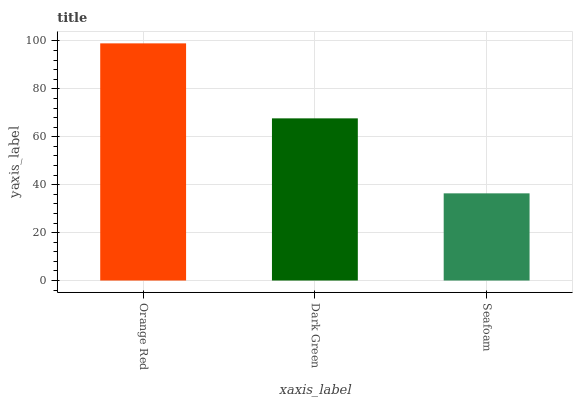Is Seafoam the minimum?
Answer yes or no. Yes. Is Orange Red the maximum?
Answer yes or no. Yes. Is Dark Green the minimum?
Answer yes or no. No. Is Dark Green the maximum?
Answer yes or no. No. Is Orange Red greater than Dark Green?
Answer yes or no. Yes. Is Dark Green less than Orange Red?
Answer yes or no. Yes. Is Dark Green greater than Orange Red?
Answer yes or no. No. Is Orange Red less than Dark Green?
Answer yes or no. No. Is Dark Green the high median?
Answer yes or no. Yes. Is Dark Green the low median?
Answer yes or no. Yes. Is Orange Red the high median?
Answer yes or no. No. Is Orange Red the low median?
Answer yes or no. No. 